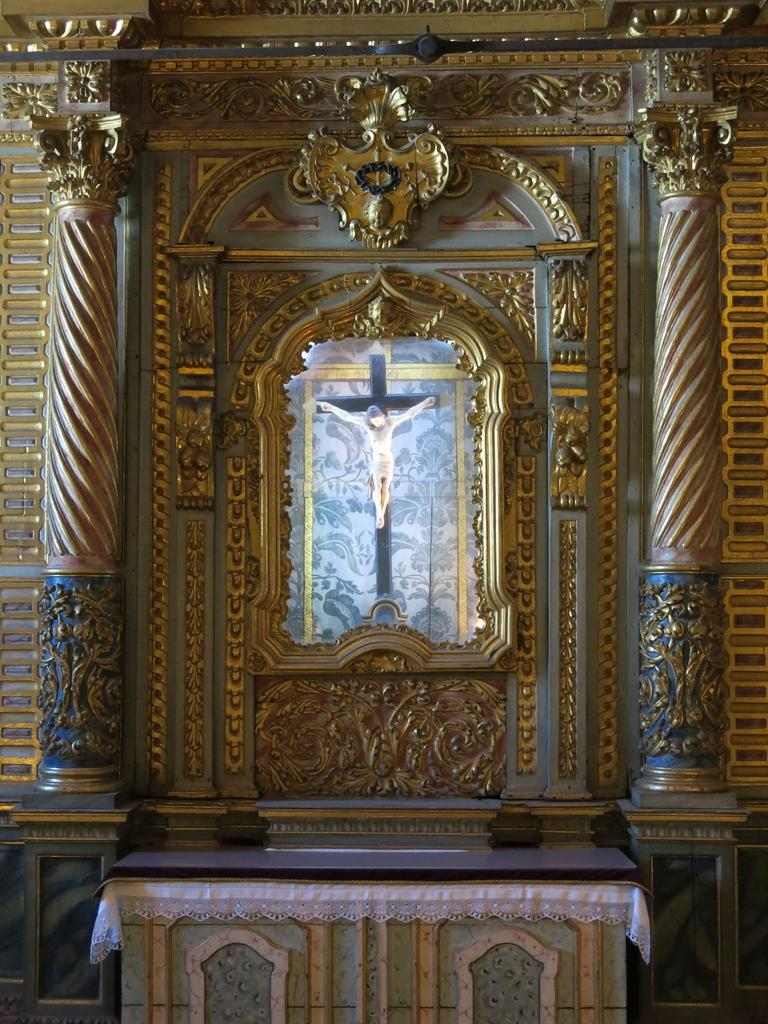What can be seen on the wall in the image? There is a wall with golden designs in the image. What architectural features are present in the image? There are pillars in the image. What is on the platform in the image? There is a platform with cloth in the image. What religious symbol can be seen in the background of the image? There is a cross with a statue in the background of the image. Can you see a patch on the wall in the image? There is no mention of a patch on the wall in the image. 